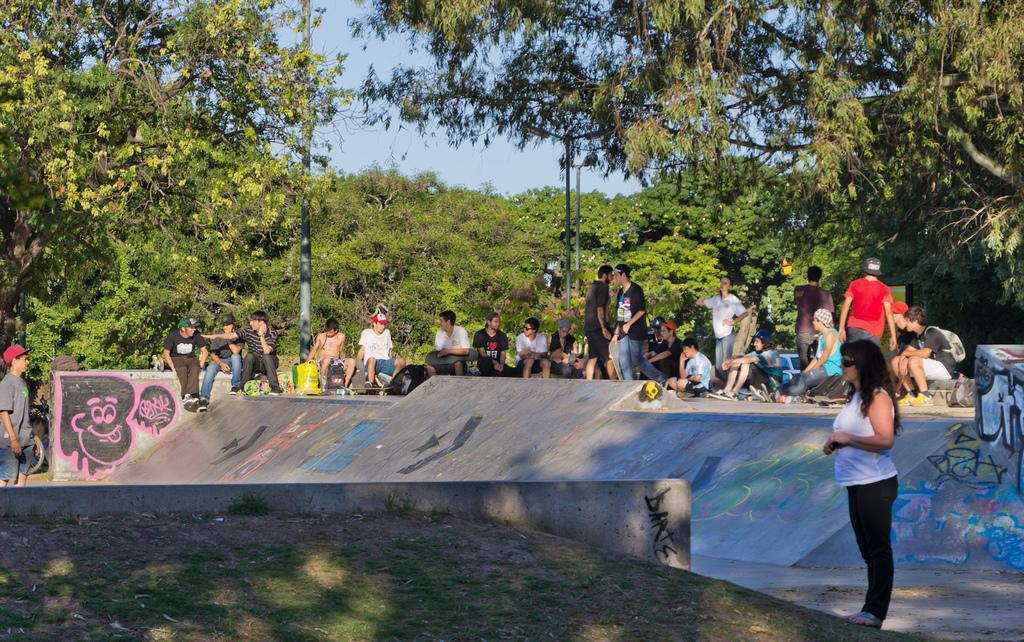Describe this image in one or two sentences. In the image we can see there are people sitting on the ground and behind there are lot of trees. 